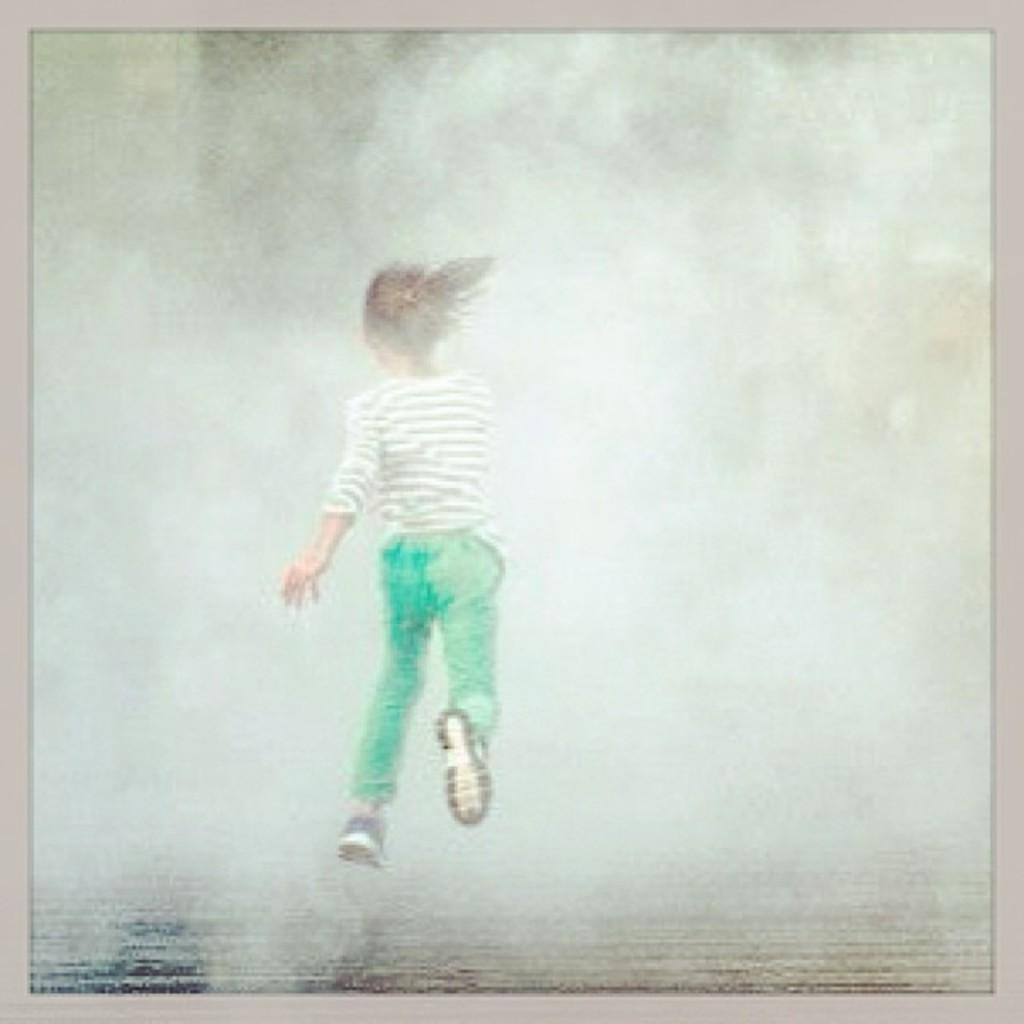What type of image is being described? The image is a photo. Who or what is the main subject of the photo? There is a girl in the center of the image. What is the girl doing in the photo? The girl is jumping. How would you describe the background of the photo? The background of the image is blurry. What type of insect can be seen crawling on the girl's shoulder in the image? There is no insect present on the girl's shoulder in the image. 